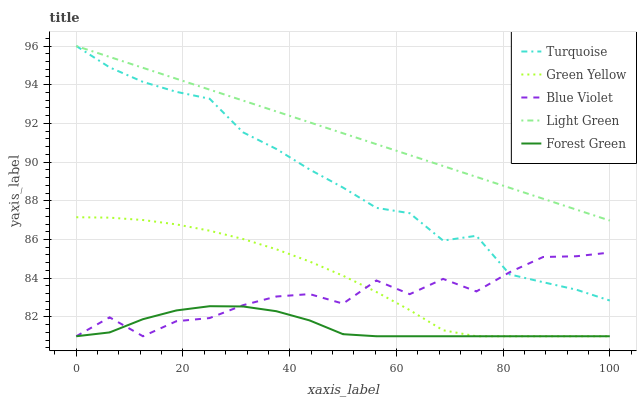Does Forest Green have the minimum area under the curve?
Answer yes or no. Yes. Does Light Green have the maximum area under the curve?
Answer yes or no. Yes. Does Turquoise have the minimum area under the curve?
Answer yes or no. No. Does Turquoise have the maximum area under the curve?
Answer yes or no. No. Is Light Green the smoothest?
Answer yes or no. Yes. Is Blue Violet the roughest?
Answer yes or no. Yes. Is Turquoise the smoothest?
Answer yes or no. No. Is Turquoise the roughest?
Answer yes or no. No. Does Forest Green have the lowest value?
Answer yes or no. Yes. Does Turquoise have the lowest value?
Answer yes or no. No. Does Light Green have the highest value?
Answer yes or no. Yes. Does Green Yellow have the highest value?
Answer yes or no. No. Is Blue Violet less than Light Green?
Answer yes or no. Yes. Is Light Green greater than Forest Green?
Answer yes or no. Yes. Does Forest Green intersect Blue Violet?
Answer yes or no. Yes. Is Forest Green less than Blue Violet?
Answer yes or no. No. Is Forest Green greater than Blue Violet?
Answer yes or no. No. Does Blue Violet intersect Light Green?
Answer yes or no. No. 